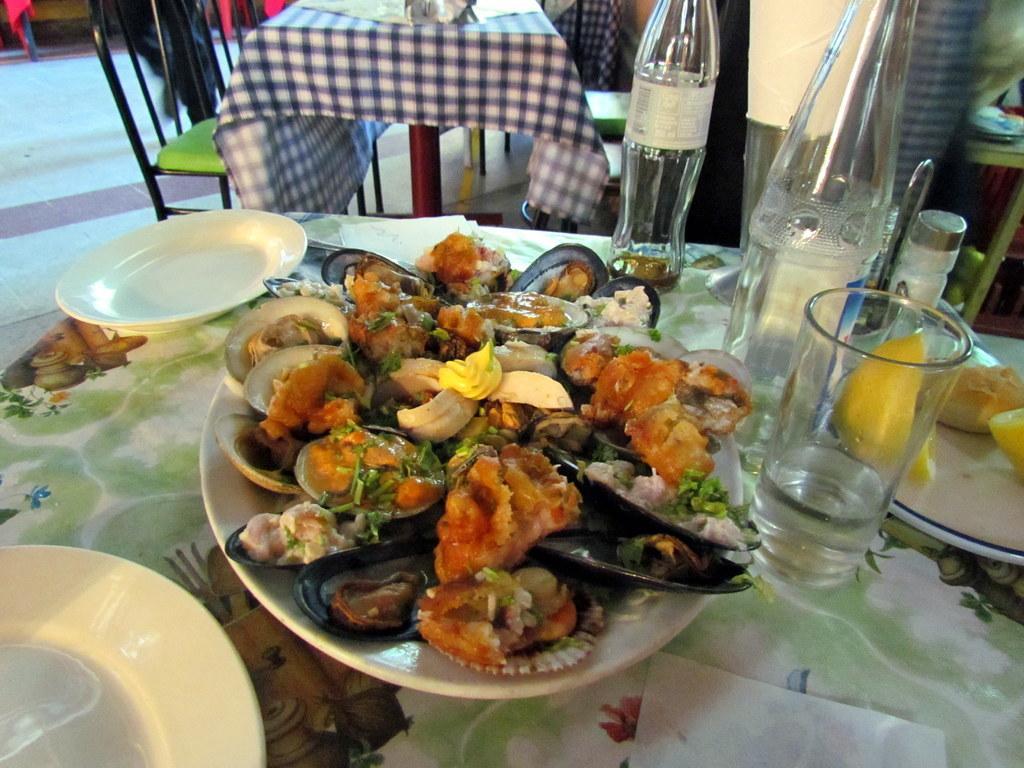How would you summarize this image in a sentence or two? In the foreground of this image, there is some food on the shells which is on the platter and there are also bottles, platters, glass, tissue and few objects on the table. At the top, there is a table, few chairs and a person walking on the floor. 